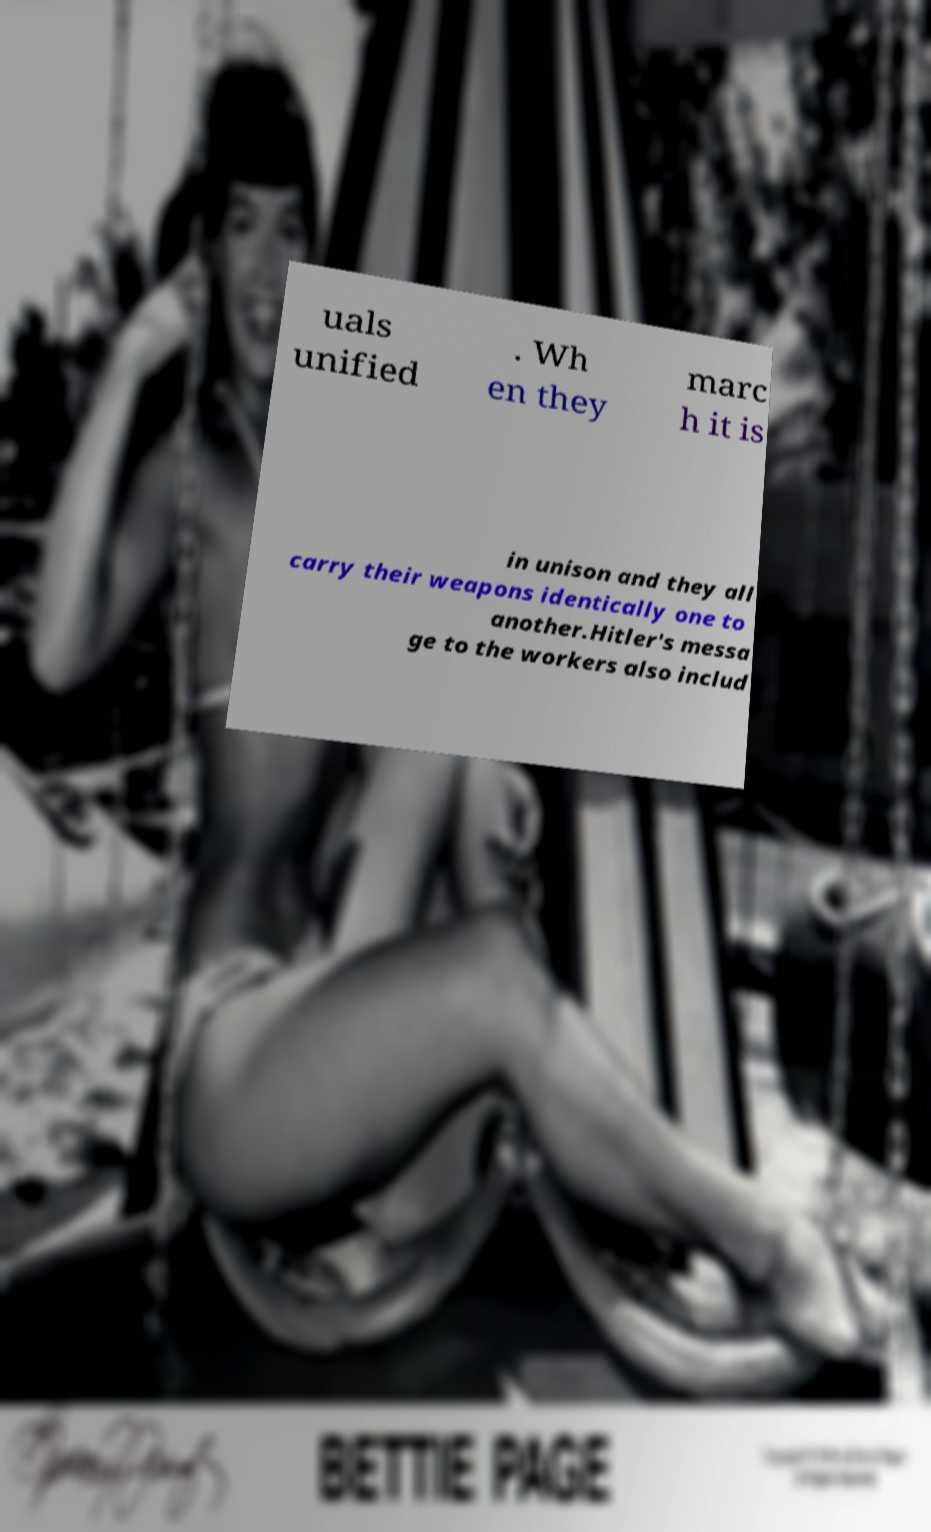I need the written content from this picture converted into text. Can you do that? uals unified . Wh en they marc h it is in unison and they all carry their weapons identically one to another.Hitler's messa ge to the workers also includ 